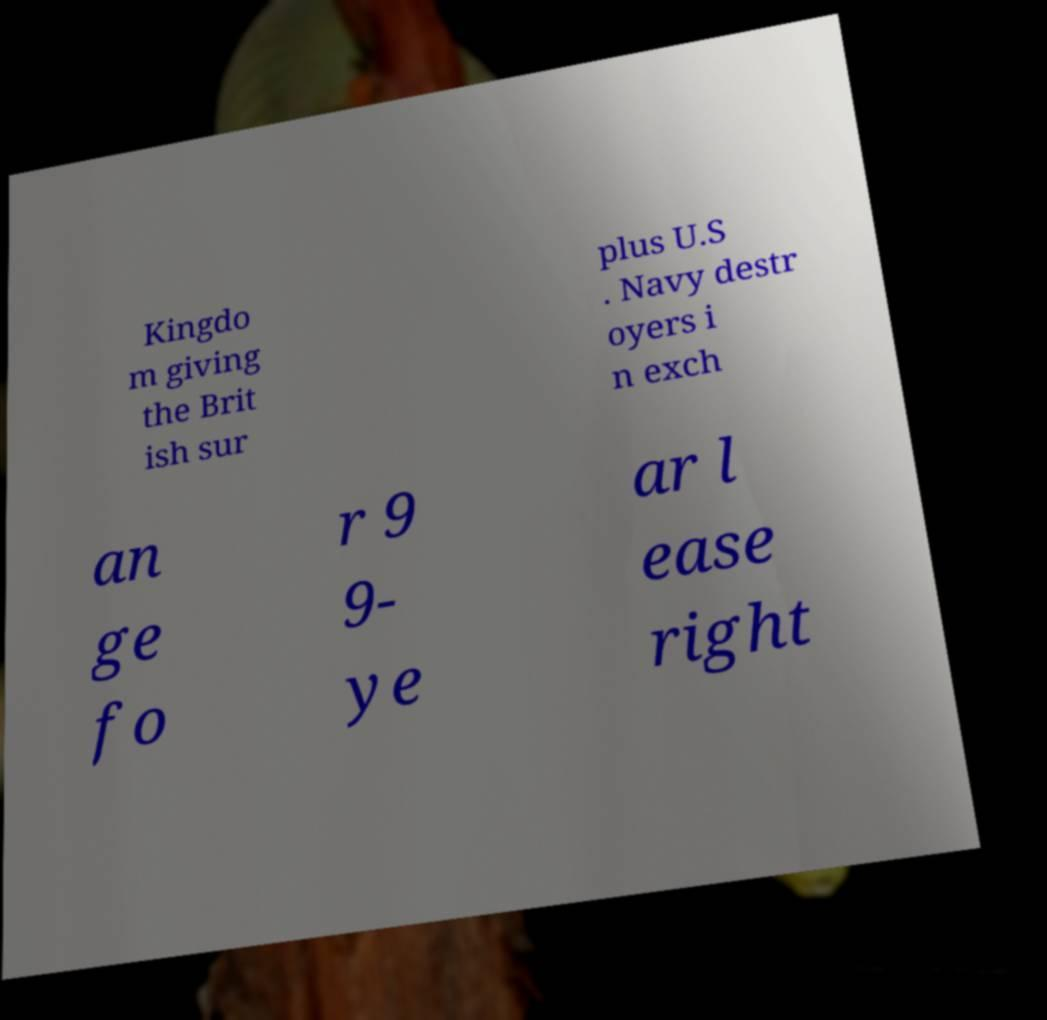Please read and relay the text visible in this image. What does it say? Kingdo m giving the Brit ish sur plus U.S . Navy destr oyers i n exch an ge fo r 9 9- ye ar l ease right 